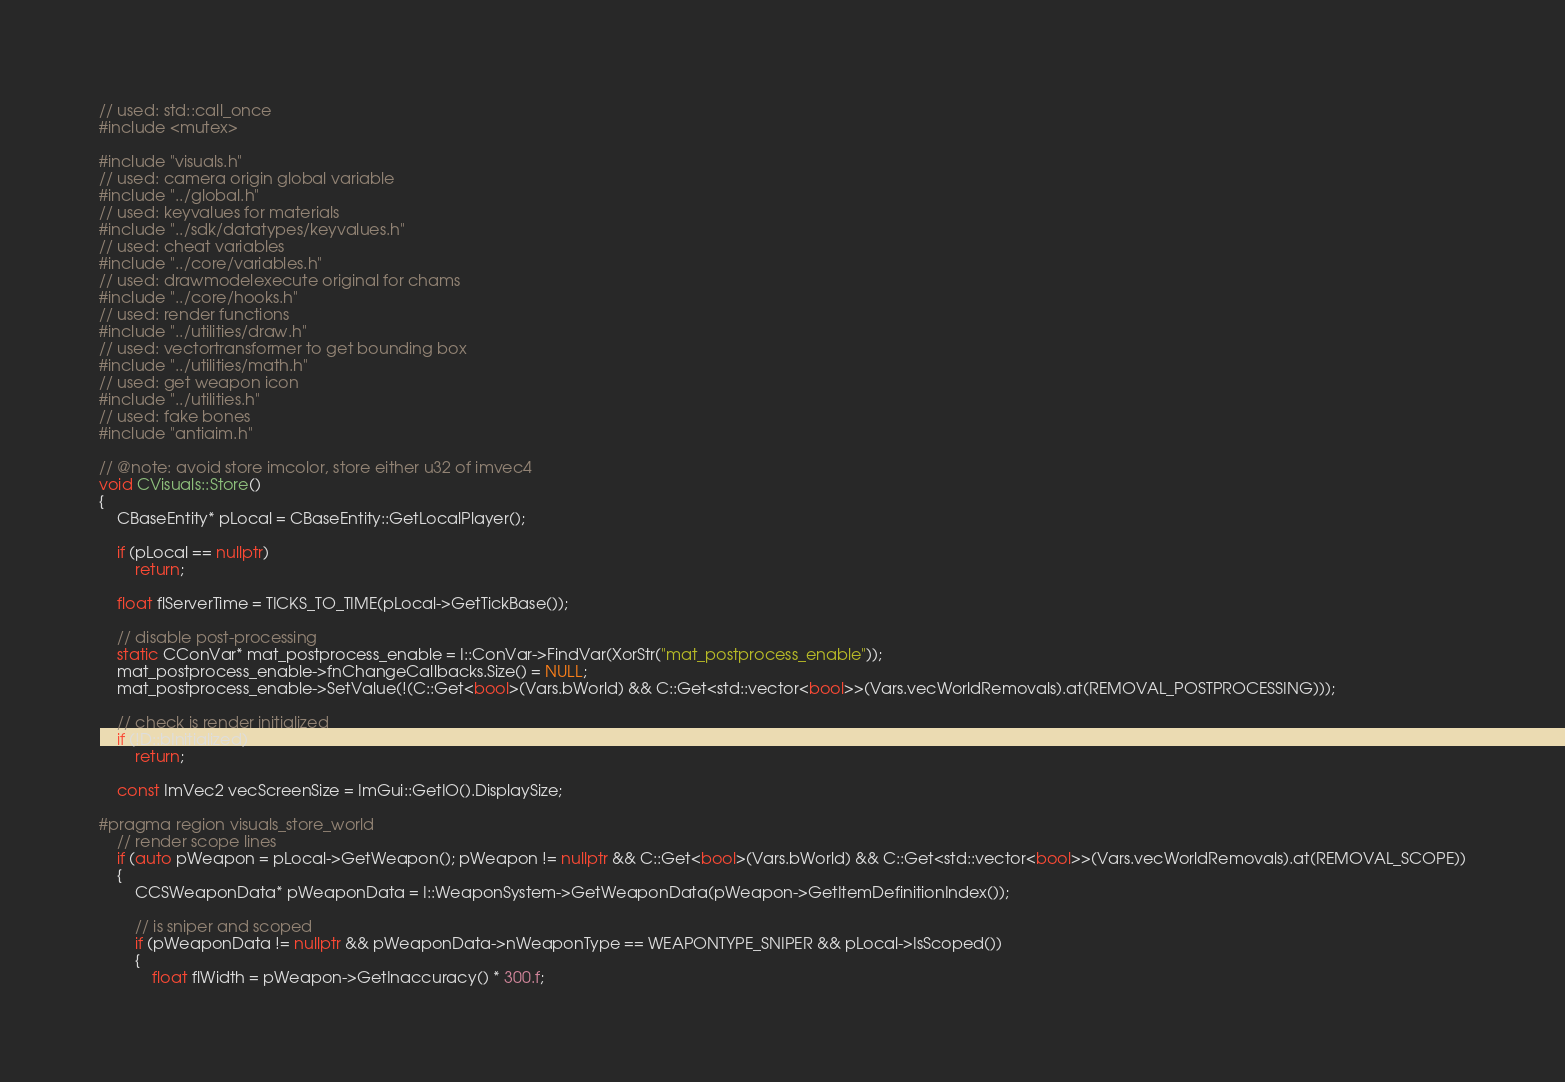Convert code to text. <code><loc_0><loc_0><loc_500><loc_500><_C++_>// used: std::call_once
#include <mutex>

#include "visuals.h"
// used: camera origin global variable
#include "../global.h"
// used: keyvalues for materials
#include "../sdk/datatypes/keyvalues.h"
// used: cheat variables
#include "../core/variables.h"
// used: drawmodelexecute original for chams
#include "../core/hooks.h"
// used: render functions
#include "../utilities/draw.h"
// used: vectortransformer to get bounding box
#include "../utilities/math.h"
// used: get weapon icon
#include "../utilities.h"
// used: fake bones
#include "antiaim.h"

// @note: avoid store imcolor, store either u32 of imvec4
void CVisuals::Store()
{
	CBaseEntity* pLocal = CBaseEntity::GetLocalPlayer();

	if (pLocal == nullptr)
		return;

	float flServerTime = TICKS_TO_TIME(pLocal->GetTickBase());

	// disable post-processing
	static CConVar* mat_postprocess_enable = I::ConVar->FindVar(XorStr("mat_postprocess_enable"));
	mat_postprocess_enable->fnChangeCallbacks.Size() = NULL;
	mat_postprocess_enable->SetValue(!(C::Get<bool>(Vars.bWorld) && C::Get<std::vector<bool>>(Vars.vecWorldRemovals).at(REMOVAL_POSTPROCESSING)));

	// check is render initialized
	if (!D::bInitialized)
		return;

	const ImVec2 vecScreenSize = ImGui::GetIO().DisplaySize;

#pragma region visuals_store_world
	// render scope lines
	if (auto pWeapon = pLocal->GetWeapon(); pWeapon != nullptr && C::Get<bool>(Vars.bWorld) && C::Get<std::vector<bool>>(Vars.vecWorldRemovals).at(REMOVAL_SCOPE))
	{
		CCSWeaponData* pWeaponData = I::WeaponSystem->GetWeaponData(pWeapon->GetItemDefinitionIndex());

		// is sniper and scoped
		if (pWeaponData != nullptr && pWeaponData->nWeaponType == WEAPONTYPE_SNIPER && pLocal->IsScoped())
		{
			float flWidth = pWeapon->GetInaccuracy() * 300.f;</code> 